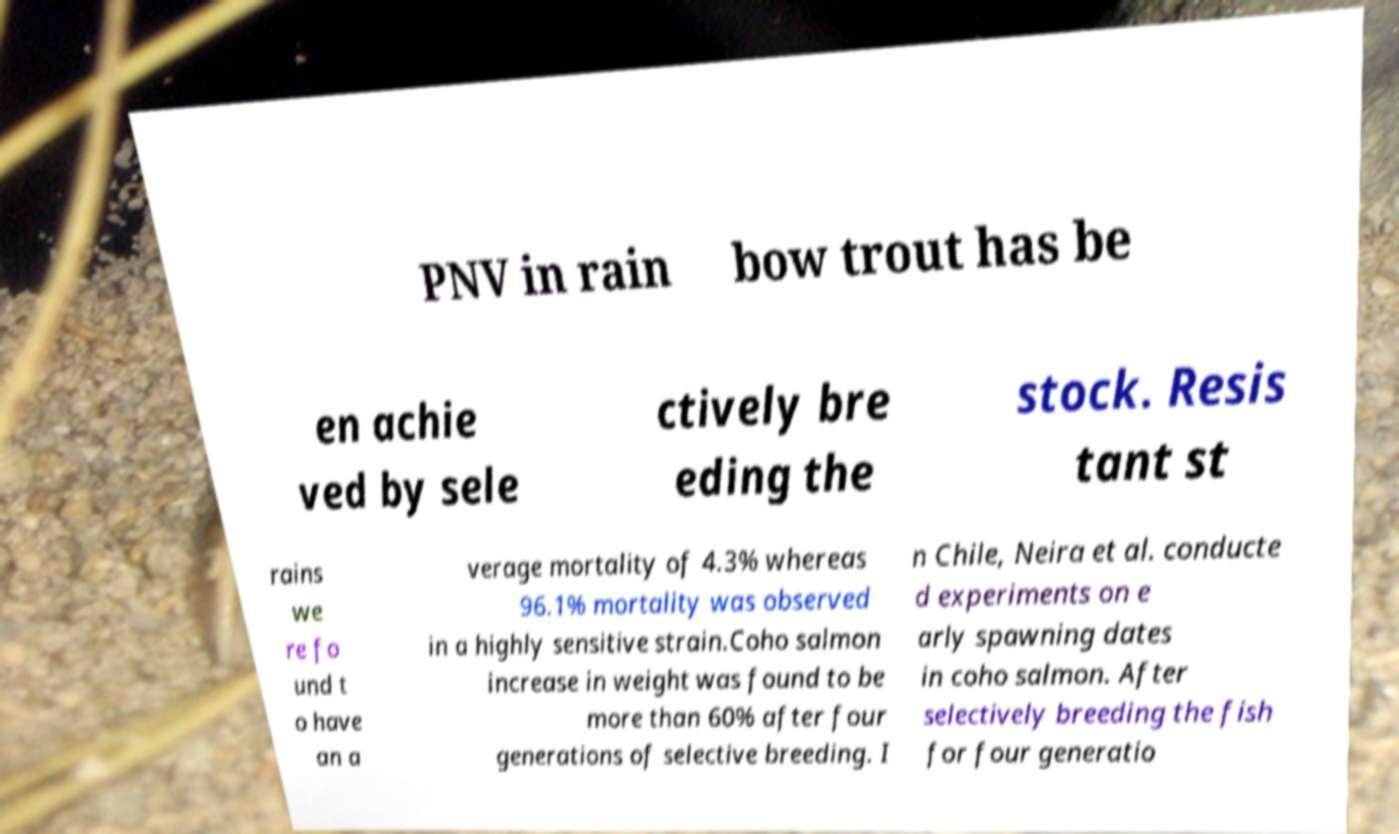Can you read and provide the text displayed in the image?This photo seems to have some interesting text. Can you extract and type it out for me? PNV in rain bow trout has be en achie ved by sele ctively bre eding the stock. Resis tant st rains we re fo und t o have an a verage mortality of 4.3% whereas 96.1% mortality was observed in a highly sensitive strain.Coho salmon increase in weight was found to be more than 60% after four generations of selective breeding. I n Chile, Neira et al. conducte d experiments on e arly spawning dates in coho salmon. After selectively breeding the fish for four generatio 